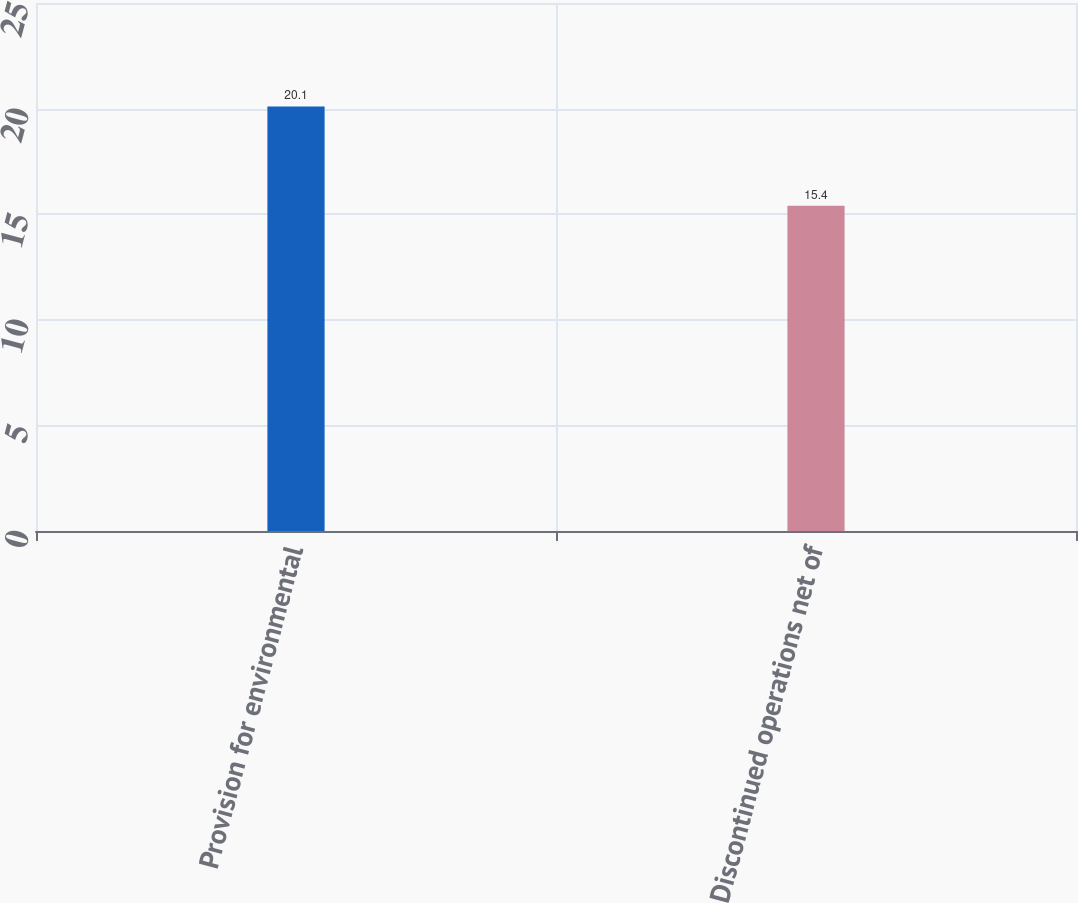Convert chart. <chart><loc_0><loc_0><loc_500><loc_500><bar_chart><fcel>Provision for environmental<fcel>Discontinued operations net of<nl><fcel>20.1<fcel>15.4<nl></chart> 